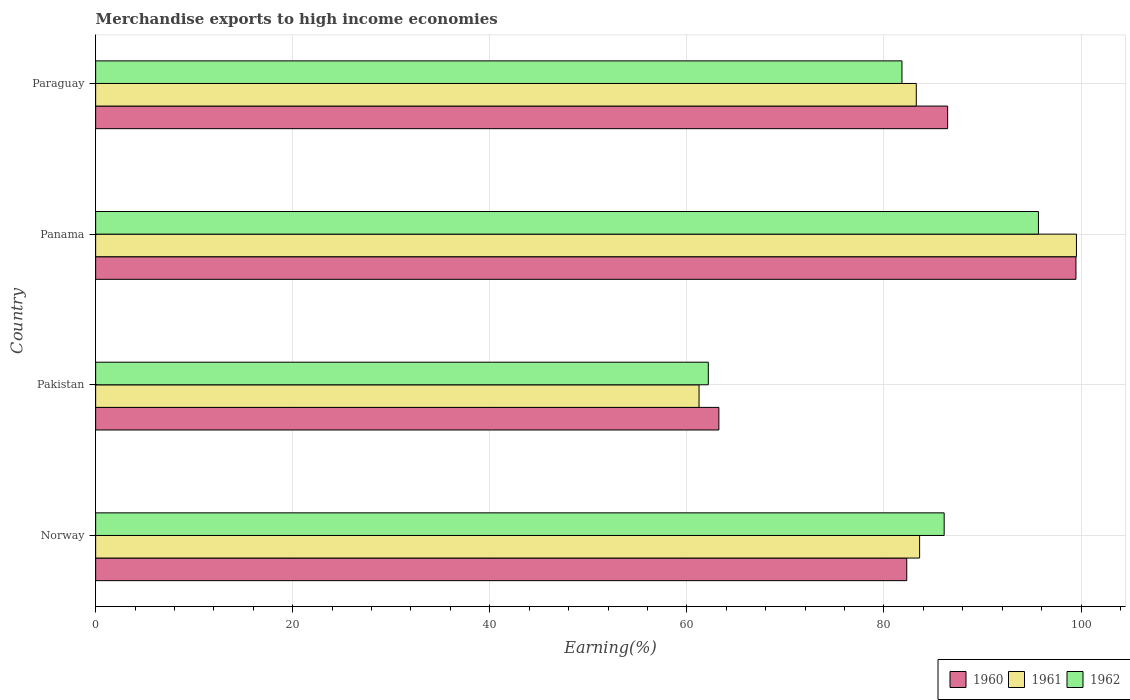How many groups of bars are there?
Ensure brevity in your answer.  4. Are the number of bars per tick equal to the number of legend labels?
Provide a short and direct response. Yes. How many bars are there on the 2nd tick from the bottom?
Keep it short and to the point. 3. What is the label of the 4th group of bars from the top?
Give a very brief answer. Norway. In how many cases, is the number of bars for a given country not equal to the number of legend labels?
Your answer should be very brief. 0. What is the percentage of amount earned from merchandise exports in 1962 in Pakistan?
Ensure brevity in your answer.  62.17. Across all countries, what is the maximum percentage of amount earned from merchandise exports in 1962?
Give a very brief answer. 95.68. Across all countries, what is the minimum percentage of amount earned from merchandise exports in 1960?
Offer a terse response. 63.25. In which country was the percentage of amount earned from merchandise exports in 1960 maximum?
Your response must be concise. Panama. In which country was the percentage of amount earned from merchandise exports in 1960 minimum?
Give a very brief answer. Pakistan. What is the total percentage of amount earned from merchandise exports in 1961 in the graph?
Offer a terse response. 327.67. What is the difference between the percentage of amount earned from merchandise exports in 1962 in Panama and that in Paraguay?
Make the answer very short. 13.85. What is the difference between the percentage of amount earned from merchandise exports in 1961 in Panama and the percentage of amount earned from merchandise exports in 1962 in Paraguay?
Your response must be concise. 17.71. What is the average percentage of amount earned from merchandise exports in 1962 per country?
Offer a very short reply. 81.45. What is the difference between the percentage of amount earned from merchandise exports in 1961 and percentage of amount earned from merchandise exports in 1962 in Pakistan?
Offer a terse response. -0.94. What is the ratio of the percentage of amount earned from merchandise exports in 1960 in Panama to that in Paraguay?
Ensure brevity in your answer.  1.15. Is the percentage of amount earned from merchandise exports in 1962 in Pakistan less than that in Panama?
Your response must be concise. Yes. Is the difference between the percentage of amount earned from merchandise exports in 1961 in Pakistan and Paraguay greater than the difference between the percentage of amount earned from merchandise exports in 1962 in Pakistan and Paraguay?
Your answer should be compact. No. What is the difference between the highest and the second highest percentage of amount earned from merchandise exports in 1961?
Offer a very short reply. 15.92. What is the difference between the highest and the lowest percentage of amount earned from merchandise exports in 1960?
Keep it short and to the point. 36.24. What does the 2nd bar from the bottom in Pakistan represents?
Your answer should be very brief. 1961. Is it the case that in every country, the sum of the percentage of amount earned from merchandise exports in 1960 and percentage of amount earned from merchandise exports in 1961 is greater than the percentage of amount earned from merchandise exports in 1962?
Keep it short and to the point. Yes. What is the difference between two consecutive major ticks on the X-axis?
Ensure brevity in your answer.  20. Are the values on the major ticks of X-axis written in scientific E-notation?
Offer a terse response. No. Does the graph contain any zero values?
Provide a succinct answer. No. How many legend labels are there?
Give a very brief answer. 3. How are the legend labels stacked?
Offer a very short reply. Horizontal. What is the title of the graph?
Provide a succinct answer. Merchandise exports to high income economies. Does "2000" appear as one of the legend labels in the graph?
Give a very brief answer. No. What is the label or title of the X-axis?
Keep it short and to the point. Earning(%). What is the Earning(%) of 1960 in Norway?
Keep it short and to the point. 82.31. What is the Earning(%) of 1961 in Norway?
Ensure brevity in your answer.  83.62. What is the Earning(%) in 1962 in Norway?
Give a very brief answer. 86.11. What is the Earning(%) of 1960 in Pakistan?
Ensure brevity in your answer.  63.25. What is the Earning(%) of 1961 in Pakistan?
Ensure brevity in your answer.  61.23. What is the Earning(%) of 1962 in Pakistan?
Provide a short and direct response. 62.17. What is the Earning(%) in 1960 in Panama?
Your response must be concise. 99.48. What is the Earning(%) of 1961 in Panama?
Ensure brevity in your answer.  99.53. What is the Earning(%) in 1962 in Panama?
Give a very brief answer. 95.68. What is the Earning(%) of 1960 in Paraguay?
Your answer should be very brief. 86.46. What is the Earning(%) of 1961 in Paraguay?
Offer a very short reply. 83.28. What is the Earning(%) in 1962 in Paraguay?
Your answer should be compact. 81.83. Across all countries, what is the maximum Earning(%) in 1960?
Offer a very short reply. 99.48. Across all countries, what is the maximum Earning(%) in 1961?
Make the answer very short. 99.53. Across all countries, what is the maximum Earning(%) in 1962?
Offer a very short reply. 95.68. Across all countries, what is the minimum Earning(%) in 1960?
Provide a succinct answer. 63.25. Across all countries, what is the minimum Earning(%) of 1961?
Your response must be concise. 61.23. Across all countries, what is the minimum Earning(%) of 1962?
Give a very brief answer. 62.17. What is the total Earning(%) in 1960 in the graph?
Give a very brief answer. 331.51. What is the total Earning(%) of 1961 in the graph?
Keep it short and to the point. 327.67. What is the total Earning(%) in 1962 in the graph?
Provide a short and direct response. 325.79. What is the difference between the Earning(%) in 1960 in Norway and that in Pakistan?
Ensure brevity in your answer.  19.07. What is the difference between the Earning(%) in 1961 in Norway and that in Pakistan?
Provide a succinct answer. 22.38. What is the difference between the Earning(%) of 1962 in Norway and that in Pakistan?
Provide a short and direct response. 23.94. What is the difference between the Earning(%) of 1960 in Norway and that in Panama?
Provide a short and direct response. -17.17. What is the difference between the Earning(%) in 1961 in Norway and that in Panama?
Offer a terse response. -15.92. What is the difference between the Earning(%) of 1962 in Norway and that in Panama?
Offer a very short reply. -9.57. What is the difference between the Earning(%) in 1960 in Norway and that in Paraguay?
Make the answer very short. -4.15. What is the difference between the Earning(%) in 1961 in Norway and that in Paraguay?
Your response must be concise. 0.34. What is the difference between the Earning(%) in 1962 in Norway and that in Paraguay?
Your answer should be very brief. 4.28. What is the difference between the Earning(%) in 1960 in Pakistan and that in Panama?
Provide a succinct answer. -36.24. What is the difference between the Earning(%) of 1961 in Pakistan and that in Panama?
Provide a succinct answer. -38.3. What is the difference between the Earning(%) of 1962 in Pakistan and that in Panama?
Offer a very short reply. -33.5. What is the difference between the Earning(%) in 1960 in Pakistan and that in Paraguay?
Your answer should be very brief. -23.22. What is the difference between the Earning(%) of 1961 in Pakistan and that in Paraguay?
Offer a terse response. -22.05. What is the difference between the Earning(%) in 1962 in Pakistan and that in Paraguay?
Give a very brief answer. -19.65. What is the difference between the Earning(%) in 1960 in Panama and that in Paraguay?
Offer a terse response. 13.02. What is the difference between the Earning(%) of 1961 in Panama and that in Paraguay?
Provide a short and direct response. 16.25. What is the difference between the Earning(%) of 1962 in Panama and that in Paraguay?
Your answer should be compact. 13.85. What is the difference between the Earning(%) of 1960 in Norway and the Earning(%) of 1961 in Pakistan?
Keep it short and to the point. 21.08. What is the difference between the Earning(%) of 1960 in Norway and the Earning(%) of 1962 in Pakistan?
Offer a very short reply. 20.14. What is the difference between the Earning(%) of 1961 in Norway and the Earning(%) of 1962 in Pakistan?
Provide a short and direct response. 21.44. What is the difference between the Earning(%) in 1960 in Norway and the Earning(%) in 1961 in Panama?
Offer a terse response. -17.22. What is the difference between the Earning(%) of 1960 in Norway and the Earning(%) of 1962 in Panama?
Make the answer very short. -13.36. What is the difference between the Earning(%) in 1961 in Norway and the Earning(%) in 1962 in Panama?
Provide a short and direct response. -12.06. What is the difference between the Earning(%) of 1960 in Norway and the Earning(%) of 1961 in Paraguay?
Provide a short and direct response. -0.97. What is the difference between the Earning(%) in 1960 in Norway and the Earning(%) in 1962 in Paraguay?
Keep it short and to the point. 0.49. What is the difference between the Earning(%) in 1961 in Norway and the Earning(%) in 1962 in Paraguay?
Give a very brief answer. 1.79. What is the difference between the Earning(%) in 1960 in Pakistan and the Earning(%) in 1961 in Panama?
Provide a short and direct response. -36.29. What is the difference between the Earning(%) in 1960 in Pakistan and the Earning(%) in 1962 in Panama?
Your response must be concise. -32.43. What is the difference between the Earning(%) of 1961 in Pakistan and the Earning(%) of 1962 in Panama?
Offer a very short reply. -34.44. What is the difference between the Earning(%) of 1960 in Pakistan and the Earning(%) of 1961 in Paraguay?
Keep it short and to the point. -20.03. What is the difference between the Earning(%) in 1960 in Pakistan and the Earning(%) in 1962 in Paraguay?
Offer a very short reply. -18.58. What is the difference between the Earning(%) of 1961 in Pakistan and the Earning(%) of 1962 in Paraguay?
Your answer should be very brief. -20.59. What is the difference between the Earning(%) of 1960 in Panama and the Earning(%) of 1961 in Paraguay?
Offer a very short reply. 16.2. What is the difference between the Earning(%) in 1960 in Panama and the Earning(%) in 1962 in Paraguay?
Offer a very short reply. 17.66. What is the difference between the Earning(%) of 1961 in Panama and the Earning(%) of 1962 in Paraguay?
Make the answer very short. 17.71. What is the average Earning(%) of 1960 per country?
Offer a very short reply. 82.88. What is the average Earning(%) in 1961 per country?
Offer a very short reply. 81.92. What is the average Earning(%) in 1962 per country?
Your response must be concise. 81.45. What is the difference between the Earning(%) in 1960 and Earning(%) in 1961 in Norway?
Give a very brief answer. -1.3. What is the difference between the Earning(%) of 1960 and Earning(%) of 1962 in Norway?
Ensure brevity in your answer.  -3.8. What is the difference between the Earning(%) in 1961 and Earning(%) in 1962 in Norway?
Ensure brevity in your answer.  -2.49. What is the difference between the Earning(%) in 1960 and Earning(%) in 1961 in Pakistan?
Your answer should be very brief. 2.01. What is the difference between the Earning(%) of 1960 and Earning(%) of 1962 in Pakistan?
Keep it short and to the point. 1.07. What is the difference between the Earning(%) of 1961 and Earning(%) of 1962 in Pakistan?
Offer a very short reply. -0.94. What is the difference between the Earning(%) in 1960 and Earning(%) in 1961 in Panama?
Offer a very short reply. -0.05. What is the difference between the Earning(%) of 1960 and Earning(%) of 1962 in Panama?
Provide a succinct answer. 3.81. What is the difference between the Earning(%) of 1961 and Earning(%) of 1962 in Panama?
Provide a succinct answer. 3.86. What is the difference between the Earning(%) in 1960 and Earning(%) in 1961 in Paraguay?
Offer a very short reply. 3.18. What is the difference between the Earning(%) in 1960 and Earning(%) in 1962 in Paraguay?
Make the answer very short. 4.64. What is the difference between the Earning(%) of 1961 and Earning(%) of 1962 in Paraguay?
Your answer should be compact. 1.45. What is the ratio of the Earning(%) of 1960 in Norway to that in Pakistan?
Provide a short and direct response. 1.3. What is the ratio of the Earning(%) of 1961 in Norway to that in Pakistan?
Give a very brief answer. 1.37. What is the ratio of the Earning(%) in 1962 in Norway to that in Pakistan?
Your answer should be compact. 1.39. What is the ratio of the Earning(%) in 1960 in Norway to that in Panama?
Offer a very short reply. 0.83. What is the ratio of the Earning(%) of 1961 in Norway to that in Panama?
Provide a succinct answer. 0.84. What is the ratio of the Earning(%) in 1962 in Norway to that in Panama?
Your response must be concise. 0.9. What is the ratio of the Earning(%) in 1960 in Norway to that in Paraguay?
Offer a terse response. 0.95. What is the ratio of the Earning(%) in 1961 in Norway to that in Paraguay?
Offer a terse response. 1. What is the ratio of the Earning(%) of 1962 in Norway to that in Paraguay?
Offer a very short reply. 1.05. What is the ratio of the Earning(%) of 1960 in Pakistan to that in Panama?
Offer a terse response. 0.64. What is the ratio of the Earning(%) in 1961 in Pakistan to that in Panama?
Your answer should be compact. 0.62. What is the ratio of the Earning(%) in 1962 in Pakistan to that in Panama?
Ensure brevity in your answer.  0.65. What is the ratio of the Earning(%) of 1960 in Pakistan to that in Paraguay?
Give a very brief answer. 0.73. What is the ratio of the Earning(%) of 1961 in Pakistan to that in Paraguay?
Your response must be concise. 0.74. What is the ratio of the Earning(%) in 1962 in Pakistan to that in Paraguay?
Provide a succinct answer. 0.76. What is the ratio of the Earning(%) in 1960 in Panama to that in Paraguay?
Ensure brevity in your answer.  1.15. What is the ratio of the Earning(%) of 1961 in Panama to that in Paraguay?
Make the answer very short. 1.2. What is the ratio of the Earning(%) of 1962 in Panama to that in Paraguay?
Provide a short and direct response. 1.17. What is the difference between the highest and the second highest Earning(%) of 1960?
Your response must be concise. 13.02. What is the difference between the highest and the second highest Earning(%) of 1961?
Offer a very short reply. 15.92. What is the difference between the highest and the second highest Earning(%) of 1962?
Offer a very short reply. 9.57. What is the difference between the highest and the lowest Earning(%) in 1960?
Your response must be concise. 36.24. What is the difference between the highest and the lowest Earning(%) of 1961?
Offer a terse response. 38.3. What is the difference between the highest and the lowest Earning(%) in 1962?
Offer a terse response. 33.5. 